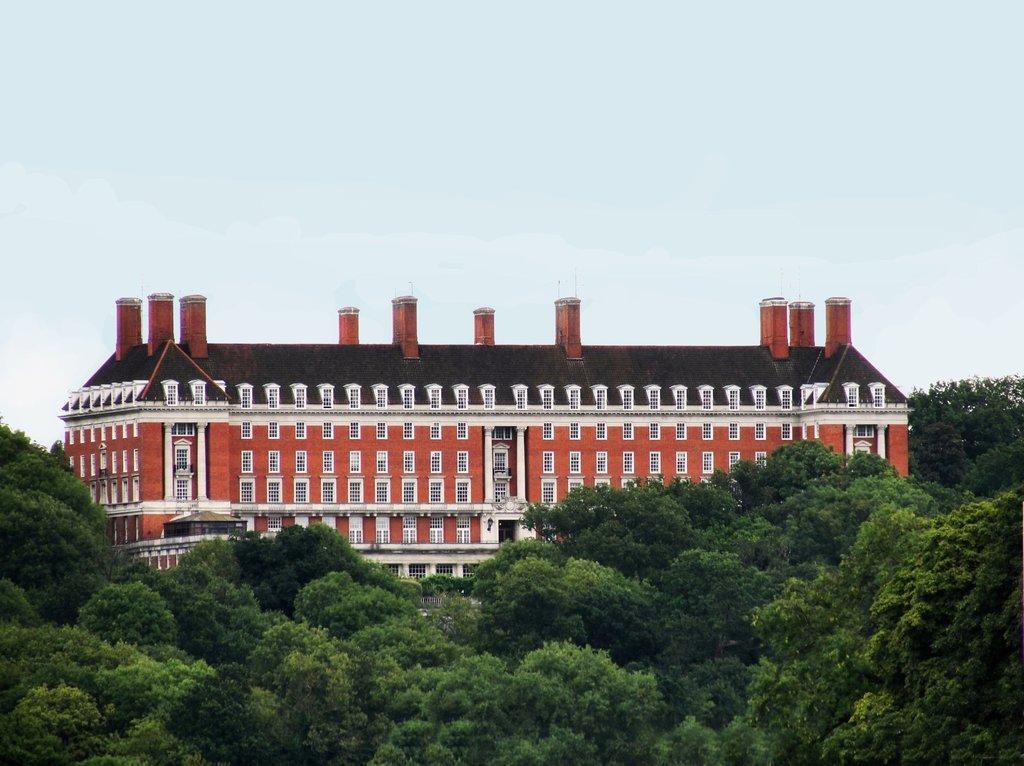Can you describe this image briefly? In the picture I can see trees, a building with many windows, we can see the pillars and the plain sky in the background. 